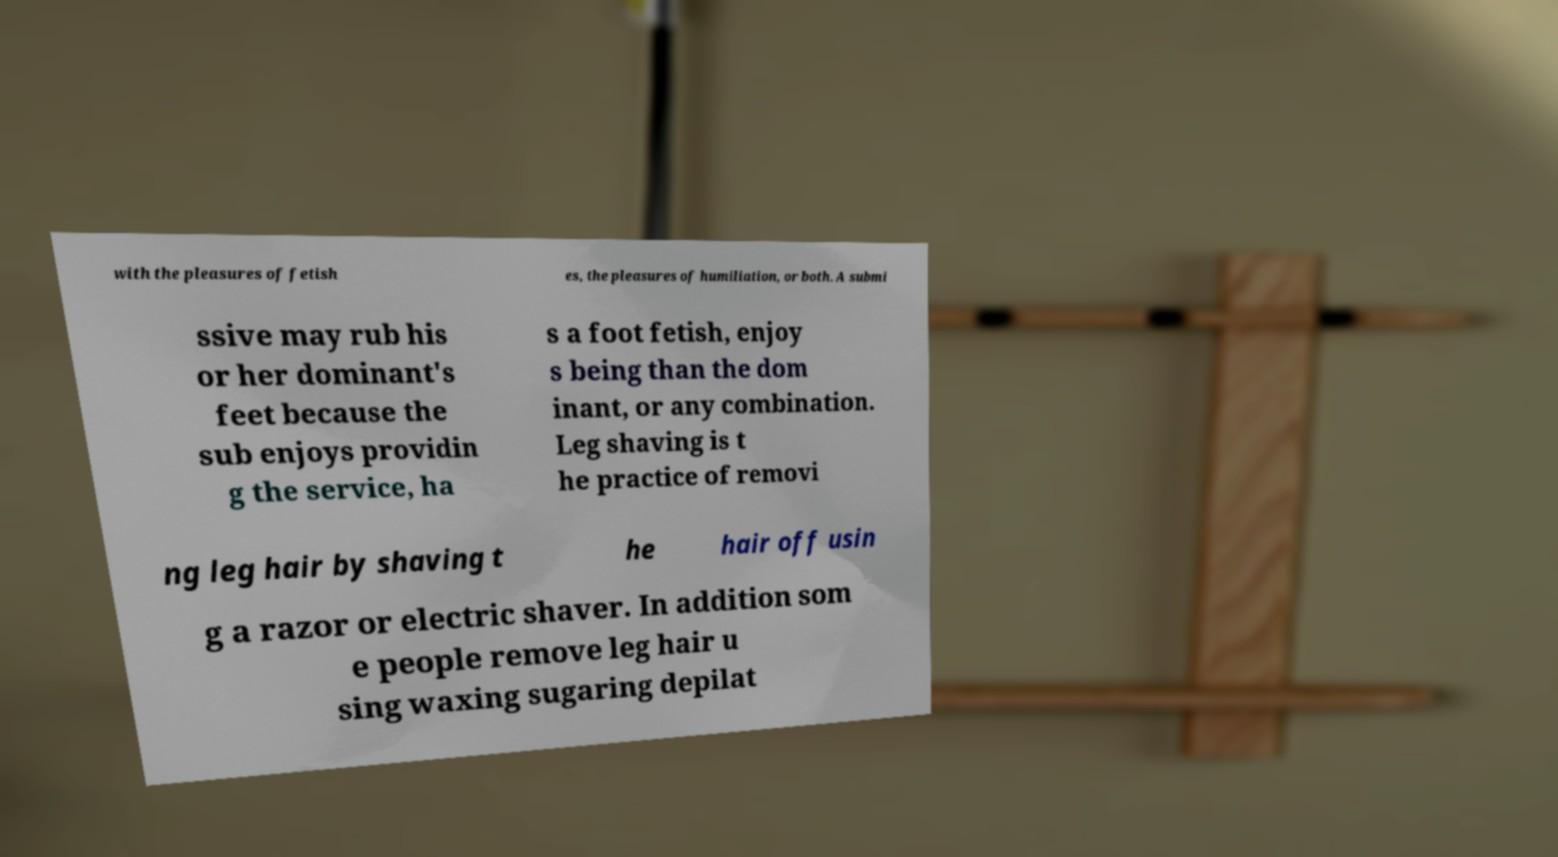What messages or text are displayed in this image? I need them in a readable, typed format. with the pleasures of fetish es, the pleasures of humiliation, or both. A submi ssive may rub his or her dominant's feet because the sub enjoys providin g the service, ha s a foot fetish, enjoy s being than the dom inant, or any combination. Leg shaving is t he practice of removi ng leg hair by shaving t he hair off usin g a razor or electric shaver. In addition som e people remove leg hair u sing waxing sugaring depilat 